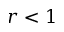Convert formula to latex. <formula><loc_0><loc_0><loc_500><loc_500>r < 1</formula> 